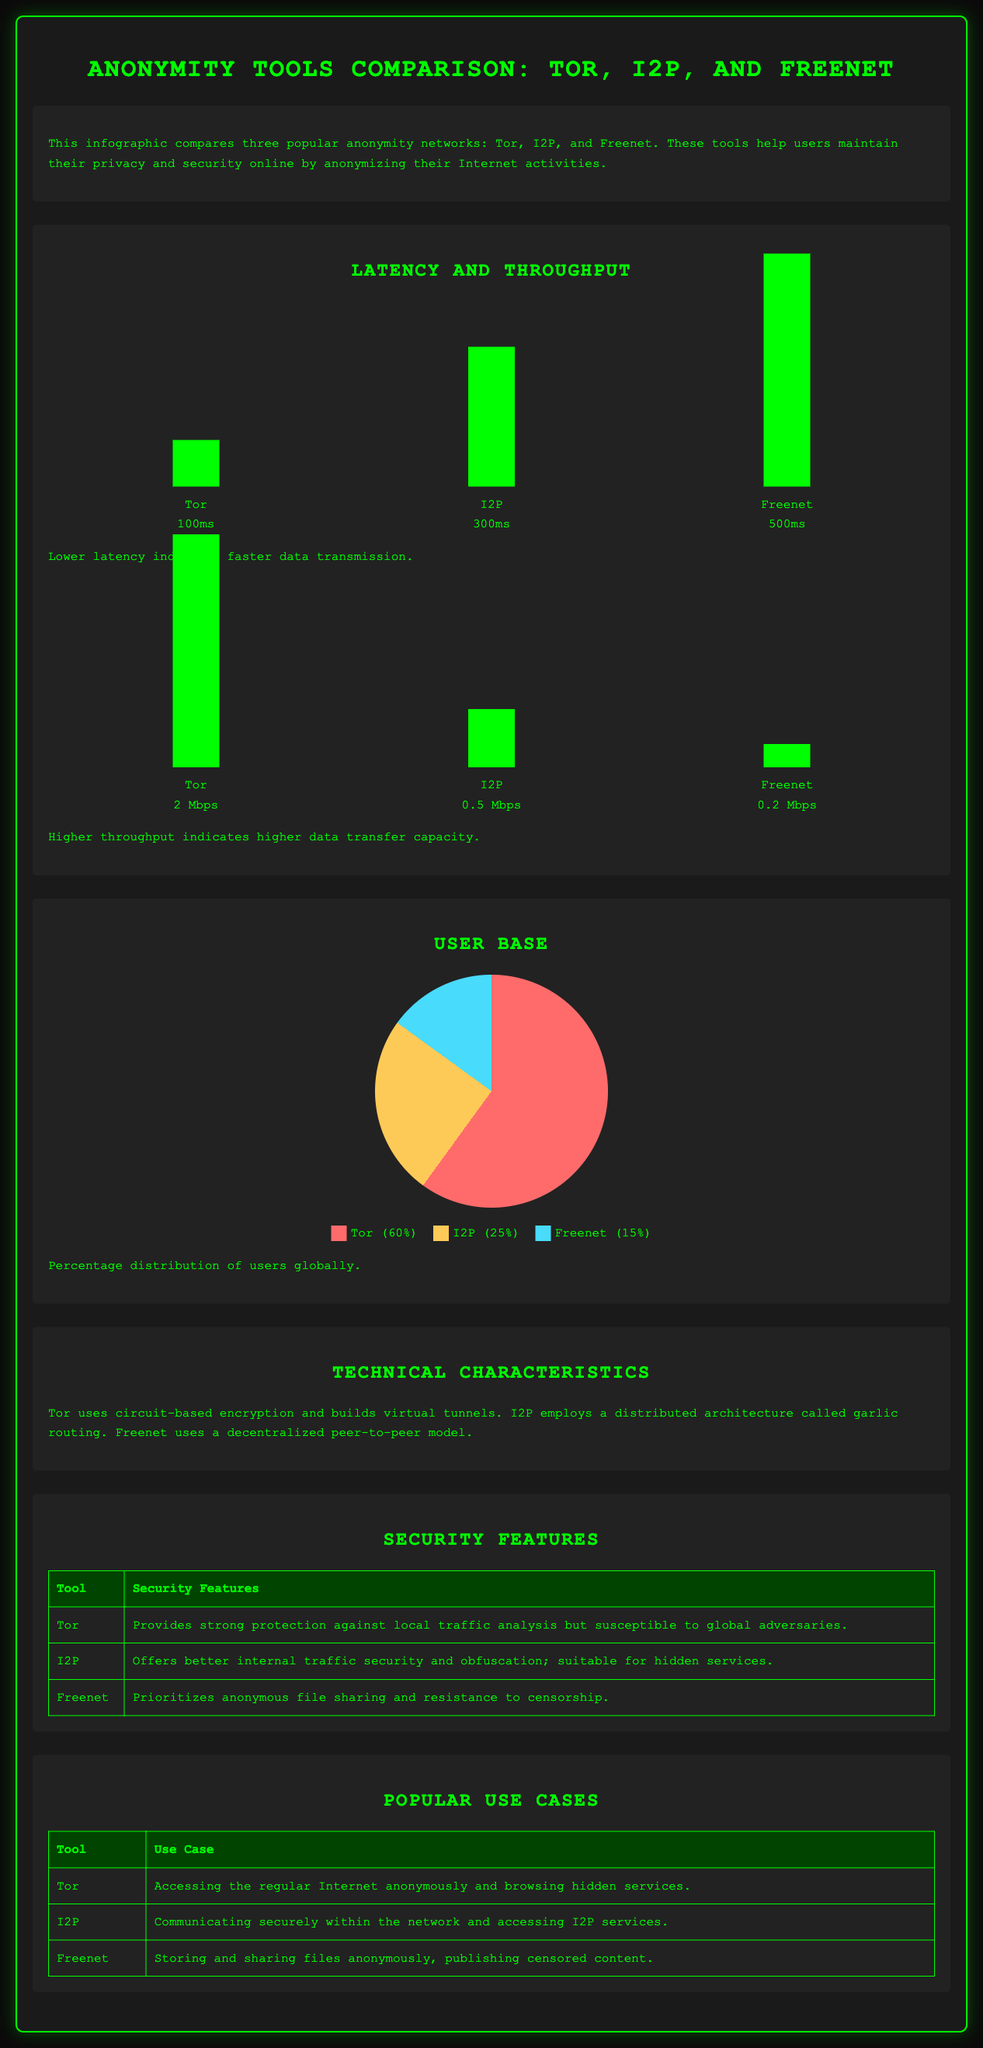what is the latency for Tor? The latency for Tor is shown as 100ms in the chart.
Answer: 100ms what is the throughput for I2P? The throughput for I2P is indicated as 0.5 Mbps in the chart.
Answer: 0.5 Mbps what percentage of users use Tor? The infographic shows that 60% of users are using Tor.
Answer: 60% which tool provides better security for internal traffic? I2P is noted to offer better internal traffic security and obfuscation.
Answer: I2P what technology does Freenet utilize? Freenet employs a decentralized peer-to-peer model according to the technical characteristics section.
Answer: decentralized peer-to-peer model how many milliseconds of latency does Freenet have? The chart specifies Freenet's latency as 500ms.
Answer: 500ms which anonymity tool has the highest user base? The chart indicates that Tor has the highest user base with 60% of the total users.
Answer: Tor what is a primary use case for I2P? According to the infographic, a primary use case for I2P is communicating securely within the network.
Answer: communicating securely within the network how many Mbps does Tor allow for data transfer? The infographic shows that Tor allows for a throughput of 2 Mbps.
Answer: 2 Mbps 